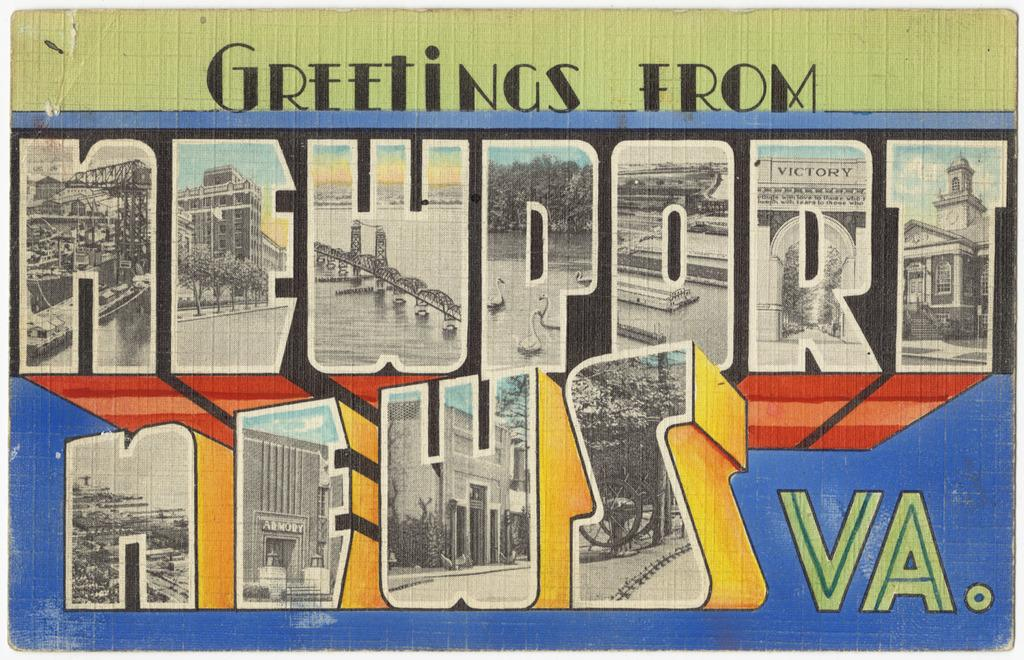<image>
Create a compact narrative representing the image presented. An old looking post card from Newport News, VA. 